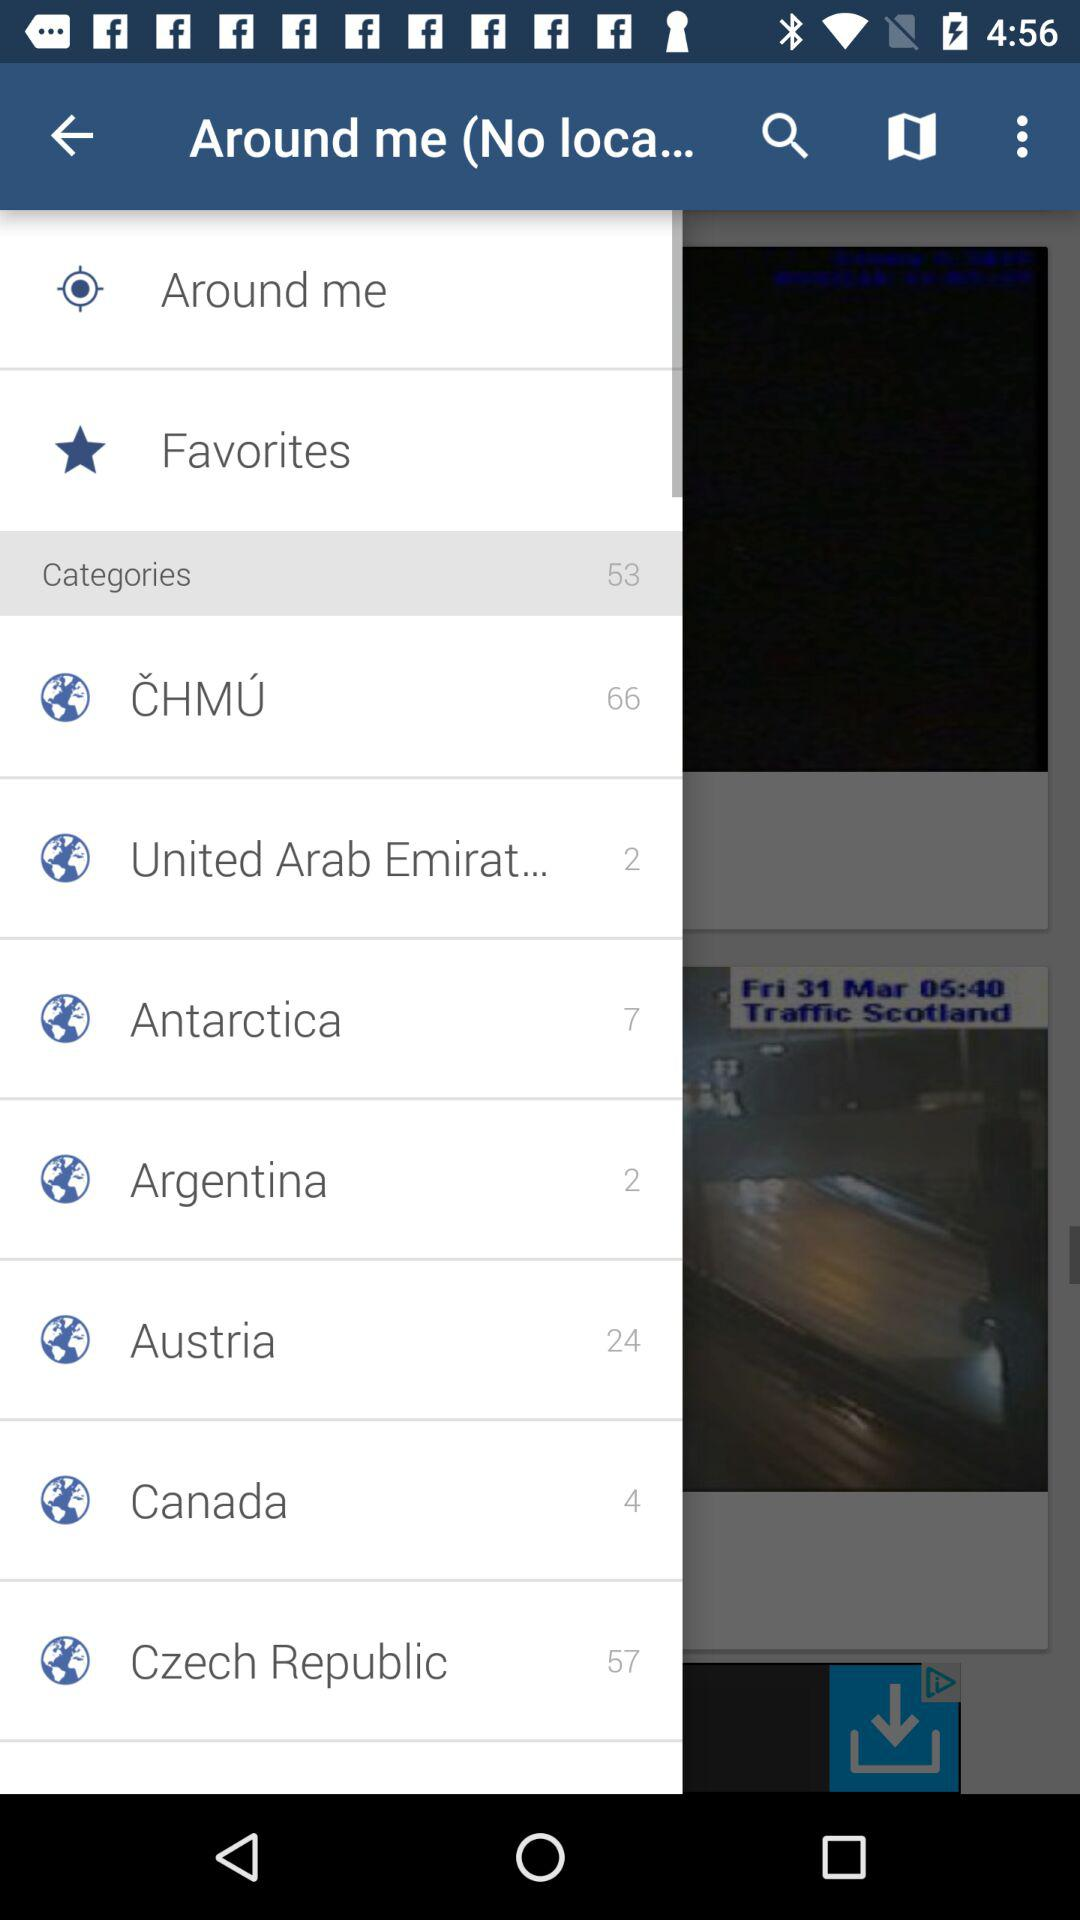The Czech Republic has how many classifications? The Czech Republic has 57 classifications. 